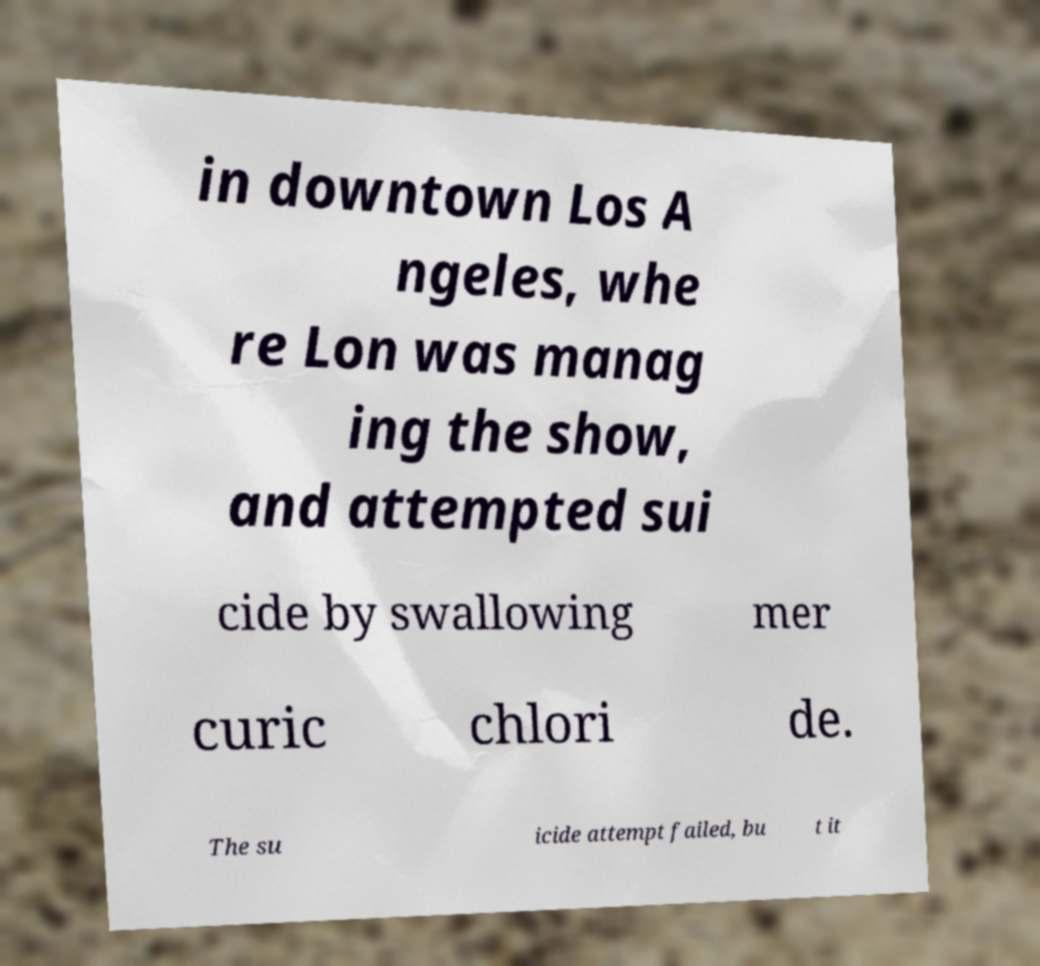Please read and relay the text visible in this image. What does it say? in downtown Los A ngeles, whe re Lon was manag ing the show, and attempted sui cide by swallowing mer curic chlori de. The su icide attempt failed, bu t it 